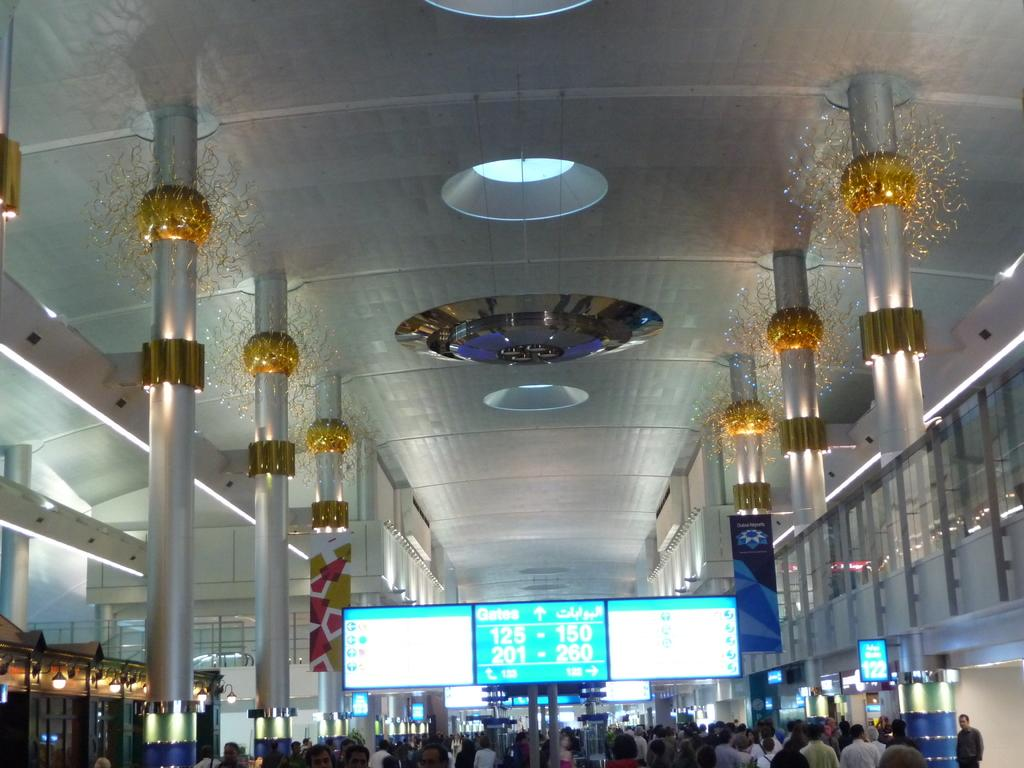Who or what can be seen in the image? There are people in the image. What type of objects are present in the image? There are screens, banners, pillars, lights, and boards in the image. What part of the room can be seen in the image? The ceiling is visible in the image. Are there any other objects or features in the image? Yes, there are other objects in the image. What type of shelf can be seen in the image? There is no shelf present in the image. Who is the owner of the banners in the image? The image does not provide information about the ownership of the banners. 